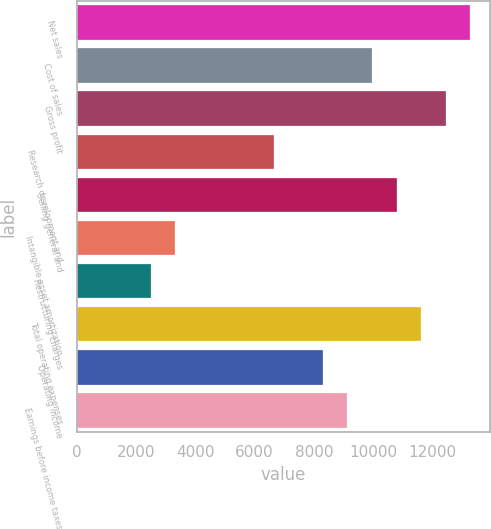<chart> <loc_0><loc_0><loc_500><loc_500><bar_chart><fcel>Net sales<fcel>Cost of sales<fcel>Gross profit<fcel>Research development and<fcel>Selling general and<fcel>Intangible asset amortization<fcel>Restructuring charges<fcel>Total operating expenses<fcel>Operating income<fcel>Earnings before income taxes<nl><fcel>13289.4<fcel>9967.8<fcel>12459<fcel>6646.2<fcel>10798.2<fcel>3324.6<fcel>2494.2<fcel>11628.6<fcel>8307<fcel>9137.4<nl></chart> 